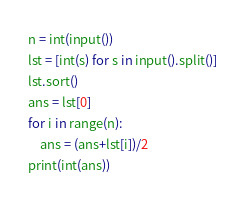<code> <loc_0><loc_0><loc_500><loc_500><_Python_>n = int(input())
lst = [int(s) for s in input().split()]
lst.sort()
ans = lst[0]
for i in range(n):
    ans = (ans+lst[i])/2
print(int(ans))
</code> 